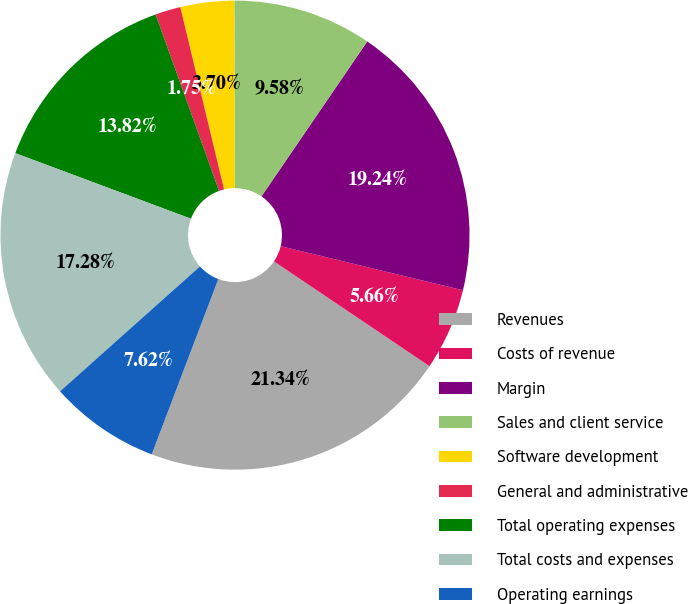Convert chart to OTSL. <chart><loc_0><loc_0><loc_500><loc_500><pie_chart><fcel>Revenues<fcel>Costs of revenue<fcel>Margin<fcel>Sales and client service<fcel>Software development<fcel>General and administrative<fcel>Total operating expenses<fcel>Total costs and expenses<fcel>Operating earnings<nl><fcel>21.34%<fcel>5.66%<fcel>19.24%<fcel>9.58%<fcel>3.7%<fcel>1.75%<fcel>13.82%<fcel>17.28%<fcel>7.62%<nl></chart> 